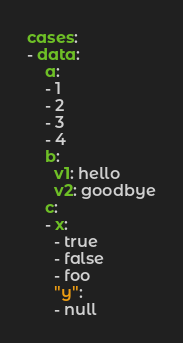<code> <loc_0><loc_0><loc_500><loc_500><_YAML_>cases:
- data:
    a:
    - 1
    - 2
    - 3
    - 4
    b:
      v1: hello
      v2: goodbye
    c:
    - x:
      - true
      - false
      - foo
      "y":
      - null</code> 